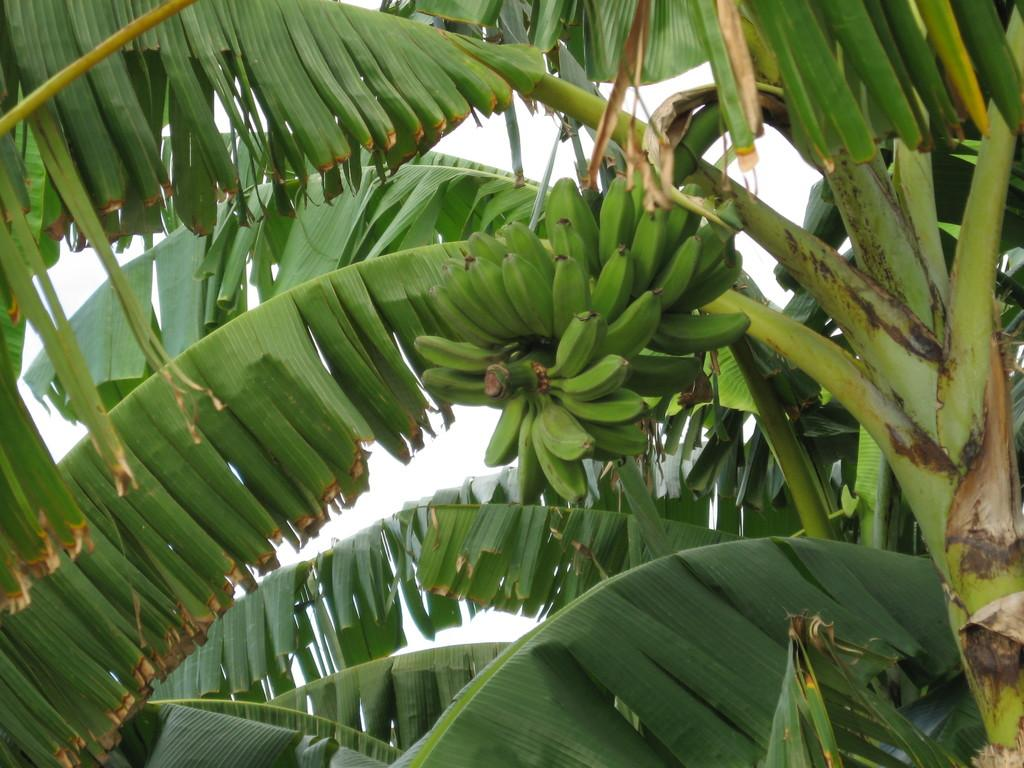What type of fruit is present in the image? There are bananas in the image. What else can be seen in the image besides the bananas? There are branches and leaves in the image. What is visible in the background of the image? The sky is visible in the background of the image. How many pairs of shoes can be seen in the image? There are no shoes present in the image. What type of bed is visible in the image? There are no beds present in the image. 